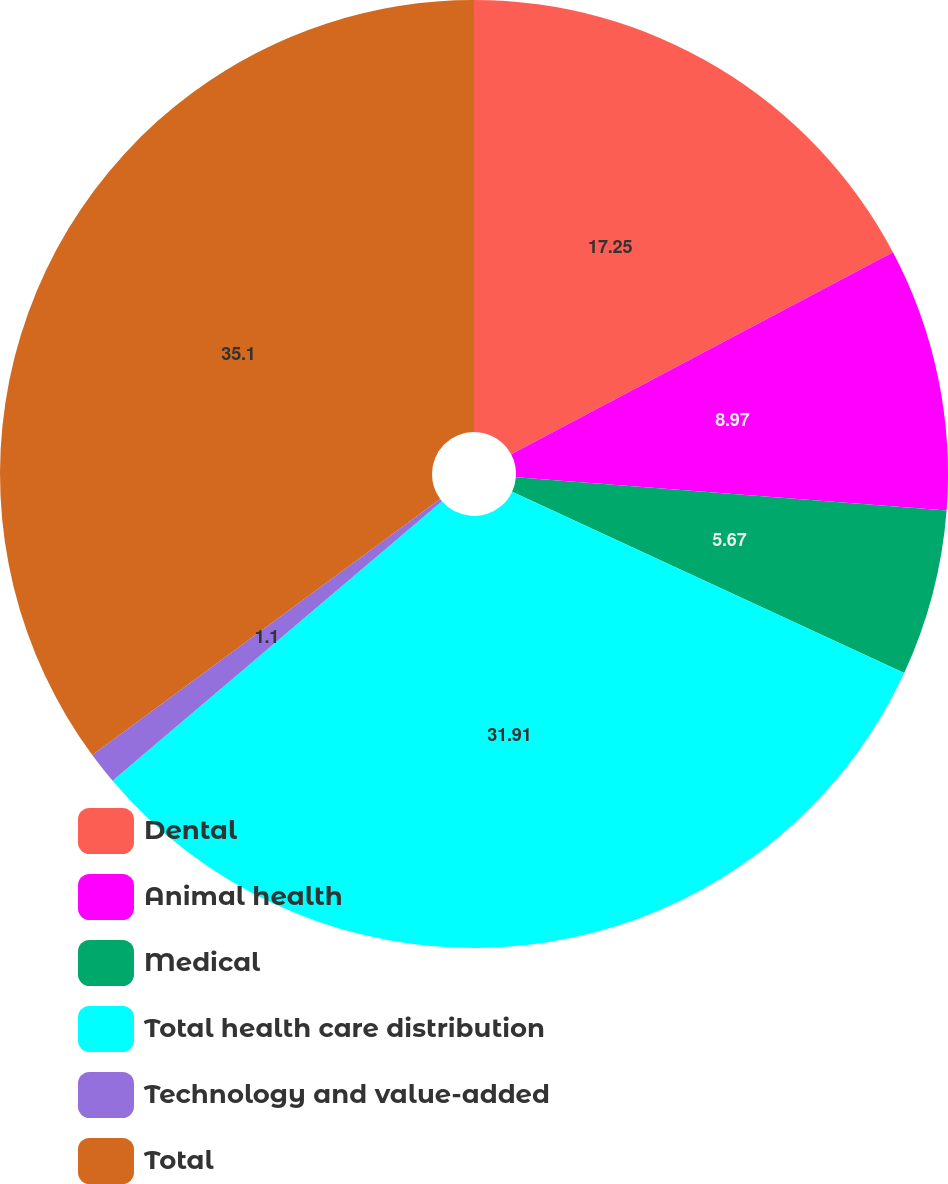<chart> <loc_0><loc_0><loc_500><loc_500><pie_chart><fcel>Dental<fcel>Animal health<fcel>Medical<fcel>Total health care distribution<fcel>Technology and value-added<fcel>Total<nl><fcel>17.25%<fcel>8.97%<fcel>5.67%<fcel>31.9%<fcel>1.1%<fcel>35.09%<nl></chart> 